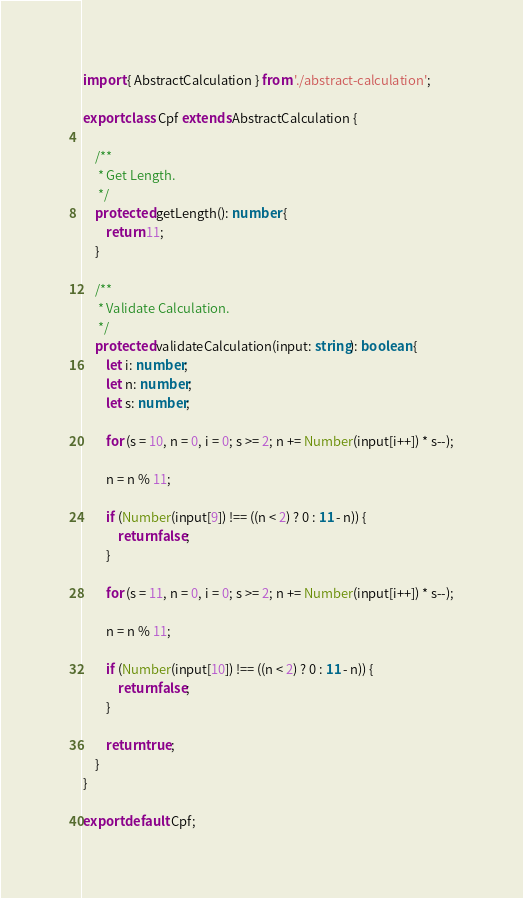<code> <loc_0><loc_0><loc_500><loc_500><_TypeScript_>import { AbstractCalculation } from './abstract-calculation';

export class Cpf extends AbstractCalculation {

    /**
     * Get Length.
     */
    protected getLength(): number {
        return 11;
    }

    /**
     * Validate Calculation.
     */
    protected validateCalculation(input: string): boolean {
        let i: number;
        let n: number;
        let s: number;

        for (s = 10, n = 0, i = 0; s >= 2; n += Number(input[i++]) * s--);

        n = n % 11;

        if (Number(input[9]) !== ((n < 2) ? 0 : 11 - n)) {
            return false;
        }

        for (s = 11, n = 0, i = 0; s >= 2; n += Number(input[i++]) * s--);

        n = n % 11;

        if (Number(input[10]) !== ((n < 2) ? 0 : 11 - n)) {
            return false;
        }

        return true;
    }
}

export default Cpf;
</code> 